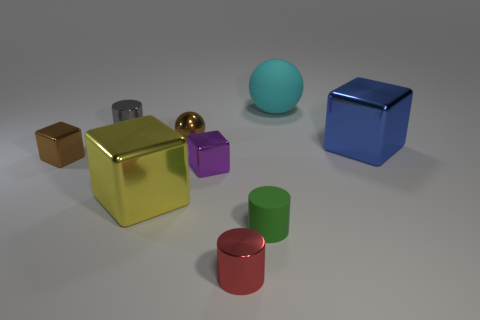The large metal thing on the right side of the large yellow object to the left of the tiny purple shiny thing is what color?
Keep it short and to the point. Blue. There is a cyan rubber object; is its shape the same as the big thing to the left of the cyan rubber object?
Your answer should be compact. No. What is the large thing behind the cylinder on the left side of the tiny cube that is on the right side of the yellow block made of?
Make the answer very short. Rubber. Is there a ball that has the same size as the yellow block?
Keep it short and to the point. Yes. There is a cyan object that is made of the same material as the tiny green object; what size is it?
Your answer should be very brief. Large. There is a blue thing; what shape is it?
Offer a terse response. Cube. Does the large cyan object have the same material as the small cylinder on the right side of the tiny red thing?
Keep it short and to the point. Yes. What number of objects are either tiny blue metallic blocks or small blocks?
Your response must be concise. 2. Is there a purple shiny ball?
Offer a very short reply. No. There is a gray shiny object right of the object that is on the left side of the gray cylinder; what shape is it?
Provide a succinct answer. Cylinder. 